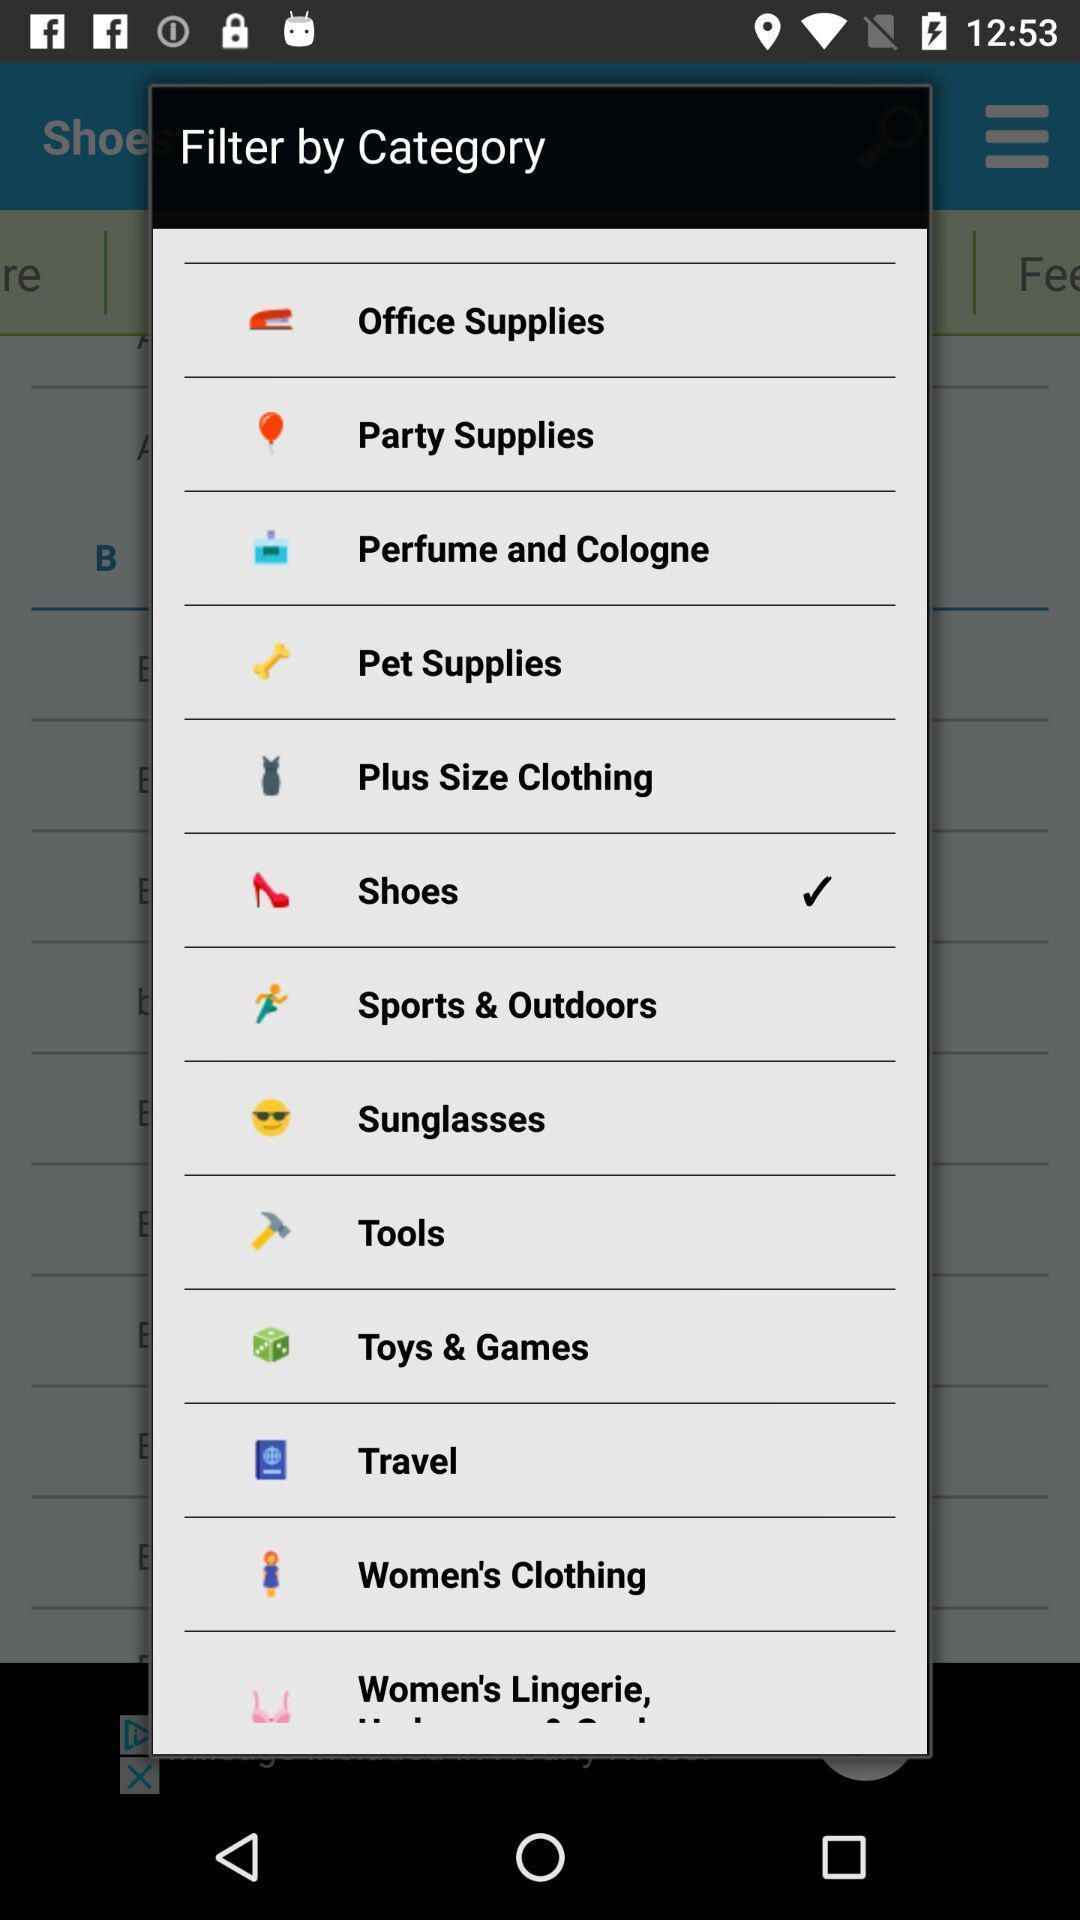What can you discern from this picture? Pop-up showing different options. 